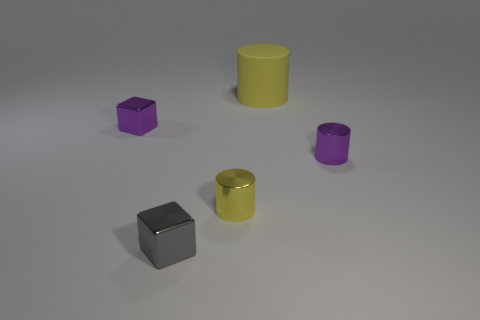Subtract all matte cylinders. How many cylinders are left? 2 Subtract all cyan cubes. How many yellow cylinders are left? 2 Add 5 big yellow cylinders. How many objects exist? 10 Subtract all cylinders. How many objects are left? 2 Subtract 1 cylinders. How many cylinders are left? 2 Subtract 0 yellow blocks. How many objects are left? 5 Subtract all purple blocks. Subtract all gray spheres. How many blocks are left? 1 Subtract all gray metallic cubes. Subtract all yellow matte cylinders. How many objects are left? 3 Add 1 cubes. How many cubes are left? 3 Add 4 metallic cylinders. How many metallic cylinders exist? 6 